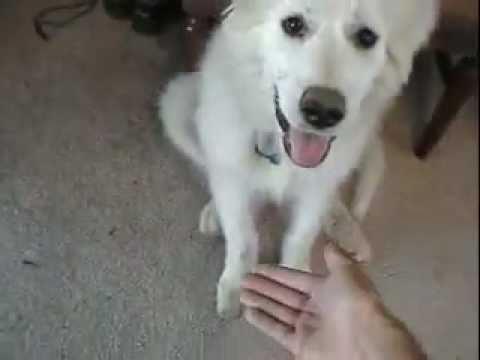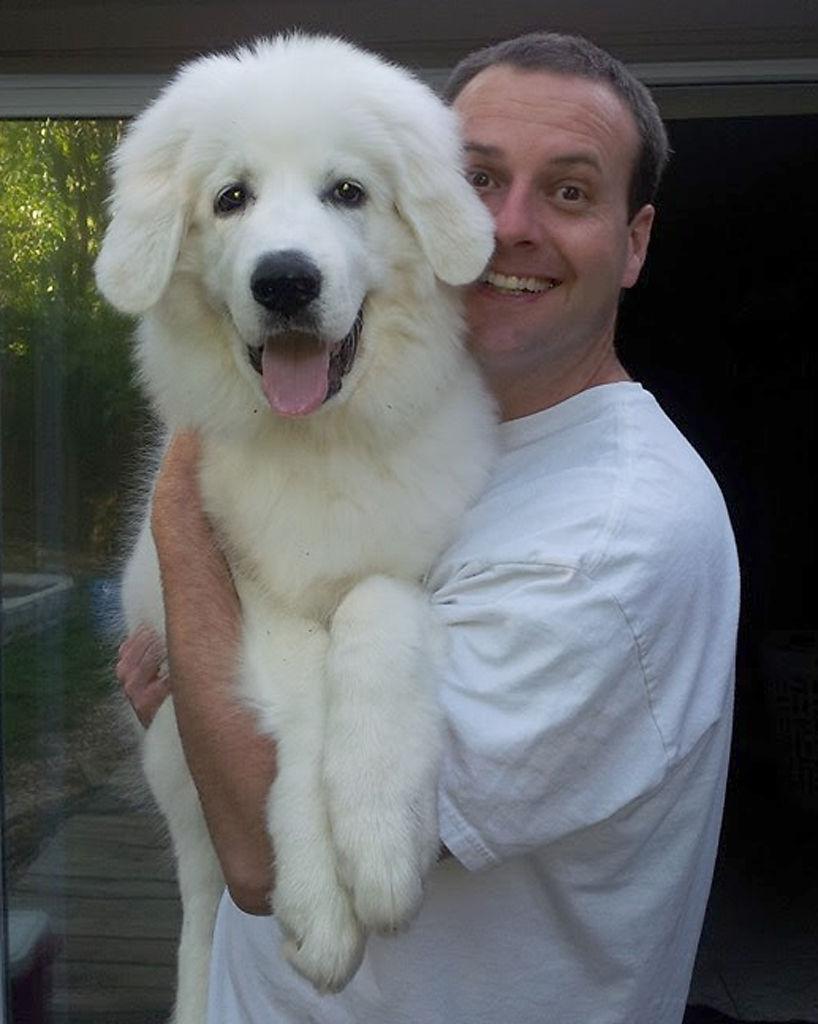The first image is the image on the left, the second image is the image on the right. For the images shown, is this caption "A person is holding a dog in one of the images." true? Answer yes or no. Yes. The first image is the image on the left, the second image is the image on the right. Evaluate the accuracy of this statement regarding the images: "In one image a large white dog is being held by a man, while the second image shows a white dog sitting near a person.". Is it true? Answer yes or no. Yes. 